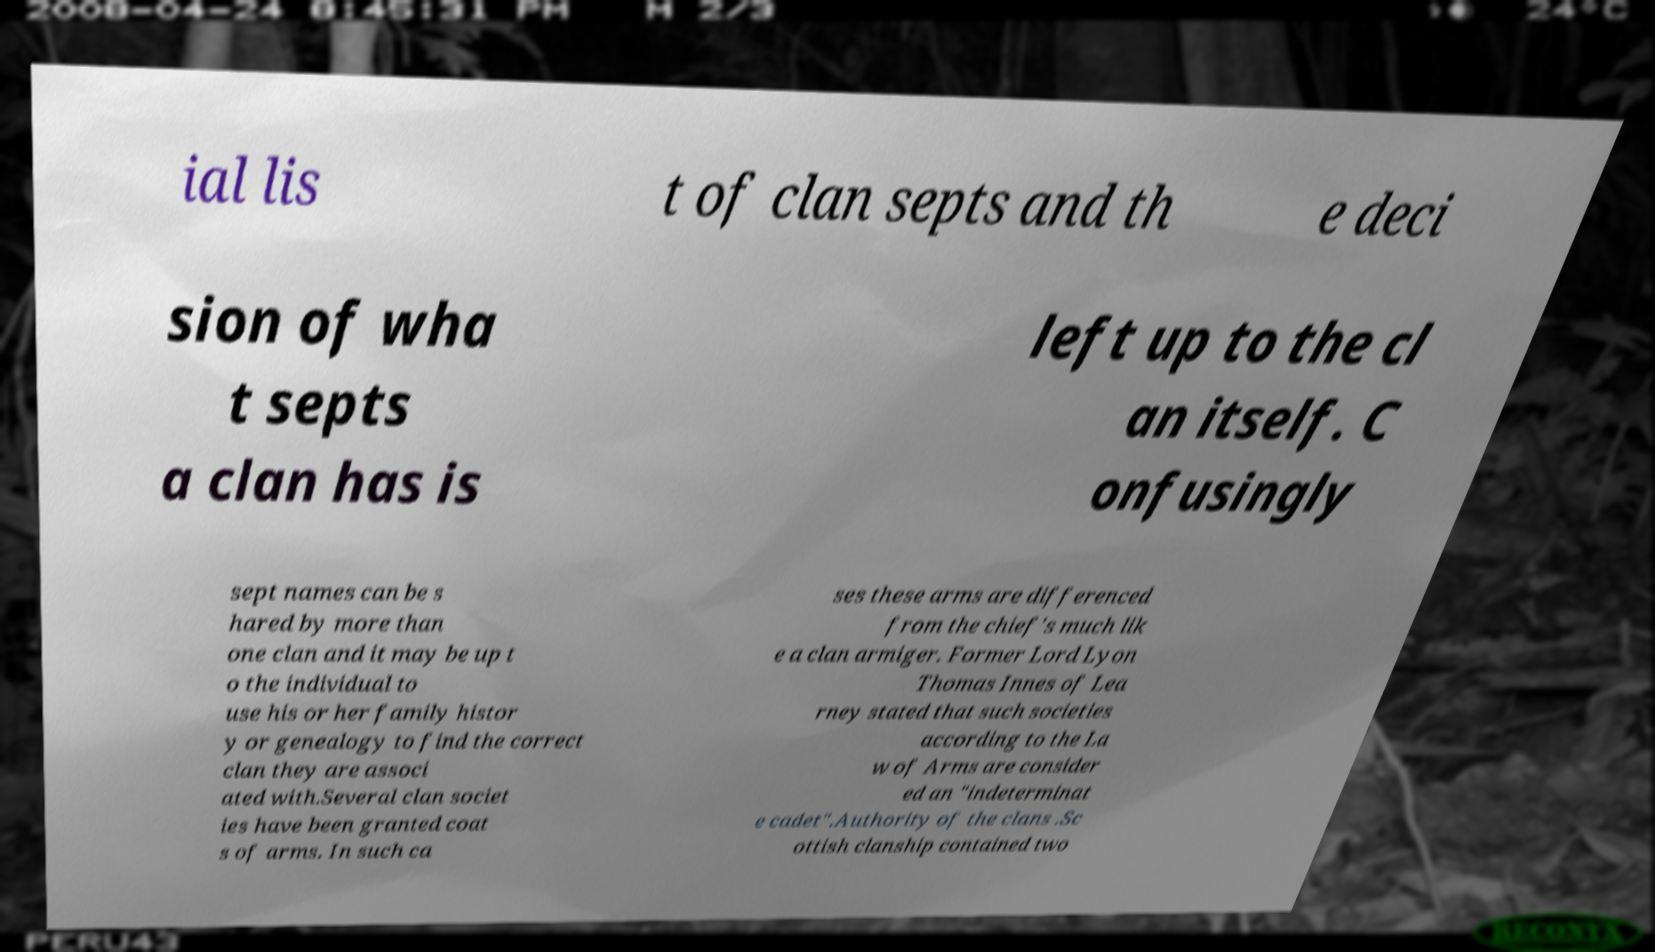For documentation purposes, I need the text within this image transcribed. Could you provide that? ial lis t of clan septs and th e deci sion of wha t septs a clan has is left up to the cl an itself. C onfusingly sept names can be s hared by more than one clan and it may be up t o the individual to use his or her family histor y or genealogy to find the correct clan they are associ ated with.Several clan societ ies have been granted coat s of arms. In such ca ses these arms are differenced from the chief's much lik e a clan armiger. Former Lord Lyon Thomas Innes of Lea rney stated that such societies according to the La w of Arms are consider ed an "indeterminat e cadet".Authority of the clans .Sc ottish clanship contained two 